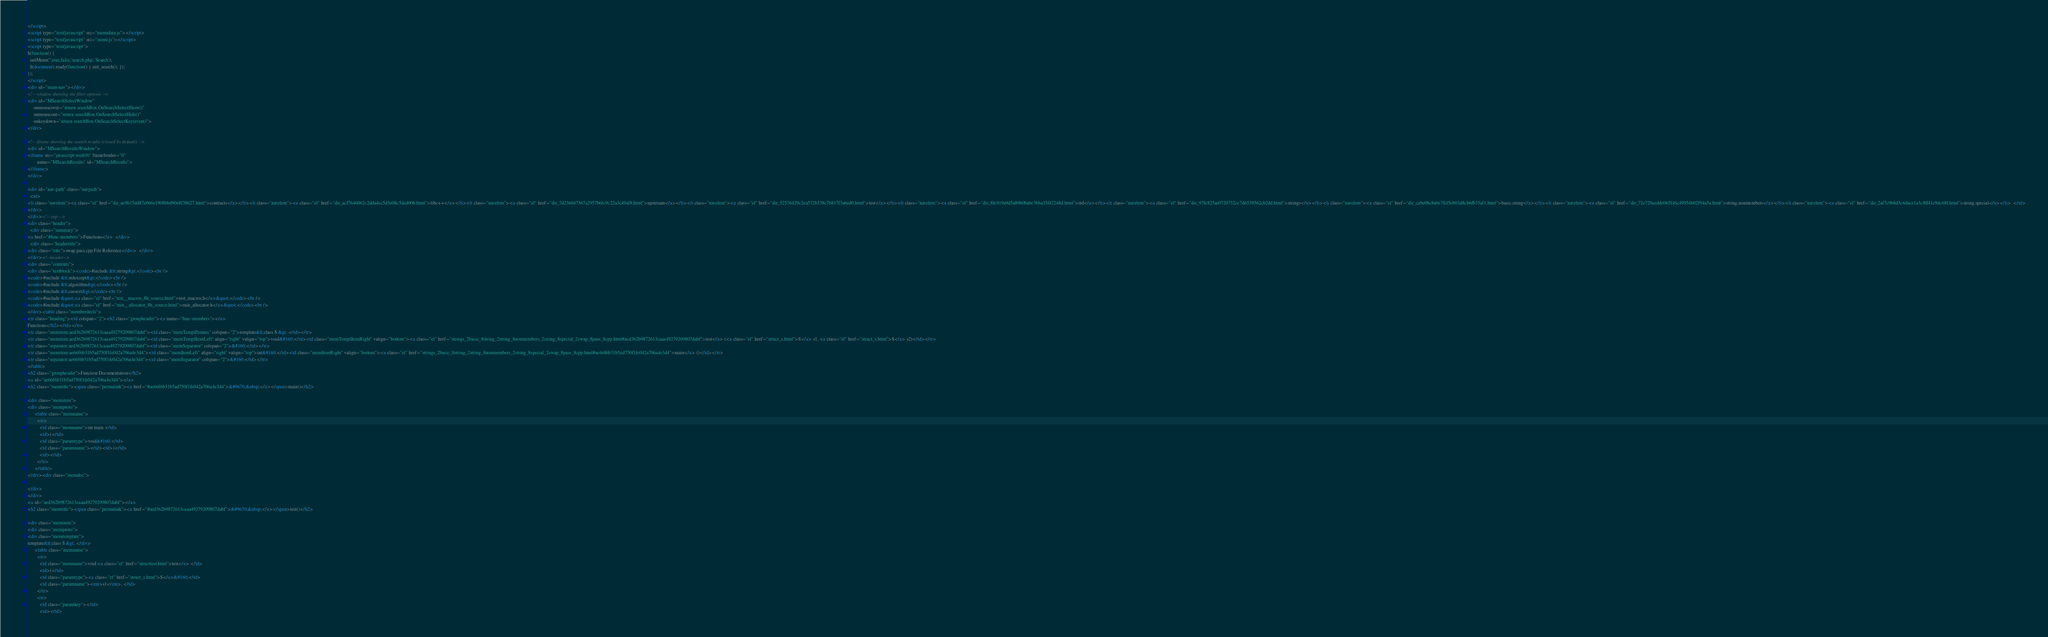Convert code to text. <code><loc_0><loc_0><loc_500><loc_500><_HTML_></script>
<script type="text/javascript" src="menudata.js"></script>
<script type="text/javascript" src="menu.js"></script>
<script type="text/javascript">
$(function() {
  initMenu('',true,false,'search.php','Search');
  $(document).ready(function() { init_search(); });
});
</script>
<div id="main-nav"></div>
<!-- window showing the filter options -->
<div id="MSearchSelectWindow"
     onmouseover="return searchBox.OnSearchSelectShow()"
     onmouseout="return searchBox.OnSearchSelectHide()"
     onkeydown="return searchBox.OnSearchSelectKey(event)">
</div>

<!-- iframe showing the search results (closed by default) -->
<div id="MSearchResultsWindow">
<iframe src="javascript:void(0)" frameborder="0" 
        name="MSearchResults" id="MSearchResults">
</iframe>
</div>

<div id="nav-path" class="navpath">
  <ul>
<li class="navelem"><a class="el" href="dir_ae9b15dd87e066e1908bbd90e8f38627.html">contracts</a></li><li class="navelem"><a class="el" href="dir_acf7646062c2dda4cc5d3e08c5ded00b.html">libc++</a></li><li class="navelem"><a class="el" href="dir_7d236047367a2957b6fc9c22a3c49af8.html">upstream</a></li><li class="navelem"><a class="el" href="dir_52576429c2ea572b538c7b817f3a6ed0.html">test</a></li><li class="navelem"><a class="el" href="dir_8fe919a9d5a89b0babe3bba35f42248d.html">std</a></li><li class="navelem"><a class="el" href="dir_97fe825ae0720752cc7d6539562cb2dd.html">strings</a></li><li class="navelem"><a class="el" href="dir_cabe0bc8a0e7fcf5eb03d8cb6fb35af1.html">basic.string</a></li><li class="navelem"><a class="el" href="dir_72e720aedde065f46c49954b02f94a5a.html">string.nonmembers</a></li><li class="navelem"><a class="el" href="dir_2af7c9b8d3c6dace1a3c8ff41c9dc68f.html">string.special</a></li>  </ul>
</div>
</div><!-- top -->
<div class="header">
  <div class="summary">
<a href="#func-members">Functions</a>  </div>
  <div class="headertitle">
<div class="title">swap.pass.cpp File Reference</div>  </div>
</div><!--header-->
<div class="contents">
<div class="textblock"><code>#include &lt;string&gt;</code><br />
<code>#include &lt;stdexcept&gt;</code><br />
<code>#include &lt;algorithm&gt;</code><br />
<code>#include &lt;cassert&gt;</code><br />
<code>#include &quot;<a class="el" href="test__macros_8h_source.html">test_macros.h</a>&quot;</code><br />
<code>#include &quot;<a class="el" href="min__allocator_8h_source.html">min_allocator.h</a>&quot;</code><br />
</div><table class="memberdecls">
<tr class="heading"><td colspan="2"><h2 class="groupheader"><a name="func-members"></a>
Functions</h2></td></tr>
<tr class="memitem:aed362b9872613caaa49279209807dabf"><td class="memTemplParams" colspan="2">template&lt;class S &gt; </td></tr>
<tr class="memitem:aed362b9872613caaa49279209807dabf"><td class="memTemplItemLeft" align="right" valign="top">void&#160;</td><td class="memTemplItemRight" valign="bottom"><a class="el" href="strings_2basic_8string_2string_8nonmembers_2string_8special_2swap_8pass_8cpp.html#aed362b9872613caaa49279209807dabf">test</a> (<a class="el" href="struct_s.html">S</a> s1, <a class="el" href="struct_s.html">S</a> s2)</td></tr>
<tr class="separator:aed362b9872613caaa49279209807dabf"><td class="memSeparator" colspan="2">&#160;</td></tr>
<tr class="memitem:ae66f6b31b5ad750f1fe042a706a4e3d4"><td class="memItemLeft" align="right" valign="top">int&#160;</td><td class="memItemRight" valign="bottom"><a class="el" href="strings_2basic_8string_2string_8nonmembers_2string_8special_2swap_8pass_8cpp.html#ae66f6b31b5ad750f1fe042a706a4e3d4">main</a> ()</td></tr>
<tr class="separator:ae66f6b31b5ad750f1fe042a706a4e3d4"><td class="memSeparator" colspan="2">&#160;</td></tr>
</table>
<h2 class="groupheader">Function Documentation</h2>
<a id="ae66f6b31b5ad750f1fe042a706a4e3d4"></a>
<h2 class="memtitle"><span class="permalink"><a href="#ae66f6b31b5ad750f1fe042a706a4e3d4">&#9670;&nbsp;</a></span>main()</h2>

<div class="memitem">
<div class="memproto">
      <table class="memname">
        <tr>
          <td class="memname">int main </td>
          <td>(</td>
          <td class="paramtype">void&#160;</td>
          <td class="paramname"></td><td>)</td>
          <td></td>
        </tr>
      </table>
</div><div class="memdoc">

</div>
</div>
<a id="aed362b9872613caaa49279209807dabf"></a>
<h2 class="memtitle"><span class="permalink"><a href="#aed362b9872613caaa49279209807dabf">&#9670;&nbsp;</a></span>test()</h2>

<div class="memitem">
<div class="memproto">
<div class="memtemplate">
template&lt;class S &gt; </div>
      <table class="memname">
        <tr>
          <td class="memname">void <a class="el" href="structtest.html">test</a> </td>
          <td>(</td>
          <td class="paramtype"><a class="el" href="struct_s.html">S</a>&#160;</td>
          <td class="paramname"><em>s1</em>, </td>
        </tr>
        <tr>
          <td class="paramkey"></td>
          <td></td></code> 